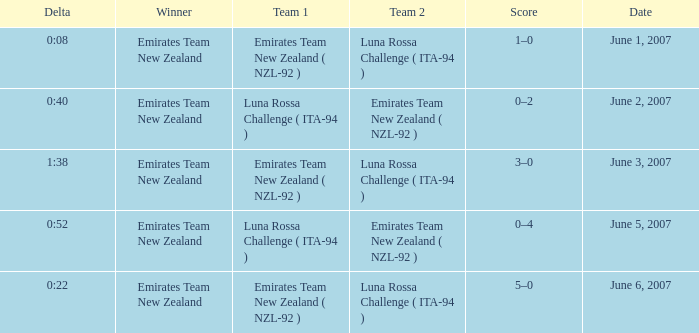On what Date is Delta 0:40? June 2, 2007. 